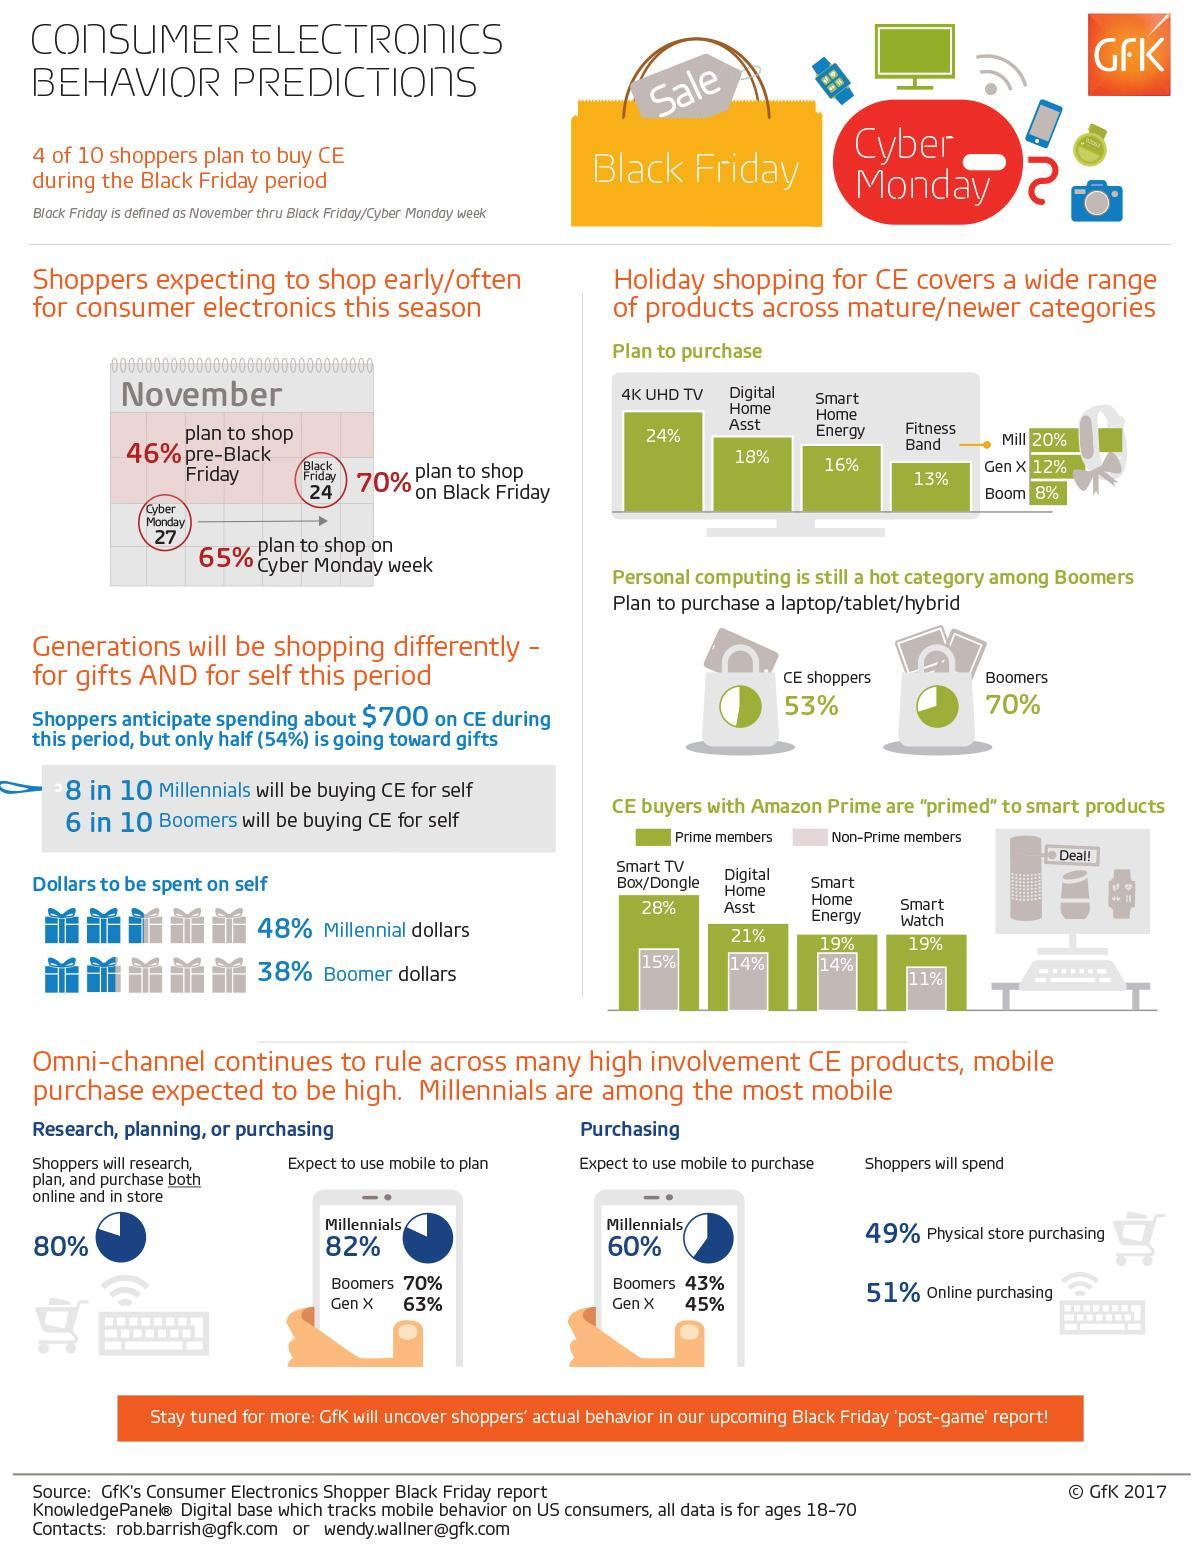What percentage of Amazon prime users buy Smart home energy or Smart watch?
Answer the question with a short phrase. 19% What percentage of Baby Boomers plan to purchase a computing gadgets, 8%, 53%, or 70%? 70% What is written on the yellow shopping bag? Black Friday Which category of people spends more money on themselves, Baby Boomers, Millenials, or Gen X? Millenials What percentage of non-prime users buy Smart home energy or Digital home assets? 14% Who among these buy fitness bands the least, Millennials, Generation X, or Baby Boomers? Baby Boomers What is the total percentage of non-prime users buying products in all four product category? 54% What is the percentage difference of  prime and non primes users buying digital home assets? 7% Which product category do most people plan to buy during the holiday season? 4K UHD TV 